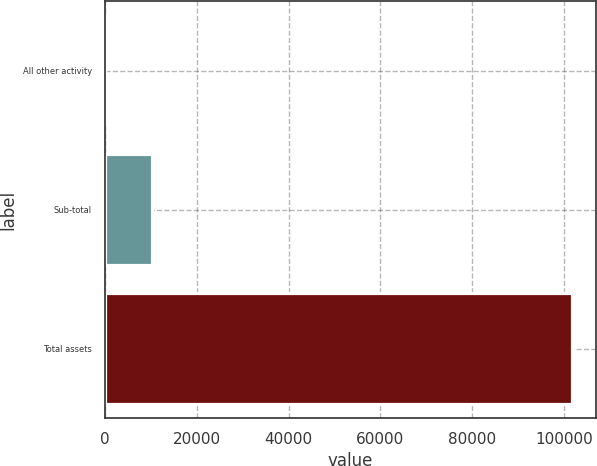Convert chart. <chart><loc_0><loc_0><loc_500><loc_500><bar_chart><fcel>All other activity<fcel>Sub-total<fcel>Total assets<nl><fcel>13<fcel>10196.2<fcel>101845<nl></chart> 